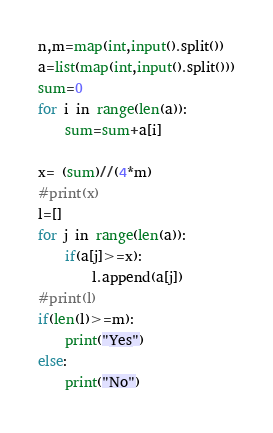<code> <loc_0><loc_0><loc_500><loc_500><_Python_>n,m=map(int,input().split())
a=list(map(int,input().split()))
sum=0
for i in range(len(a)):
    sum=sum+a[i]
    
x= (sum)//(4*m)
#print(x)
l=[]
for j in range(len(a)):
    if(a[j]>=x):
        l.append(a[j])
#print(l)        
if(len(l)>=m):
    print("Yes")
else:
    print("No")
</code> 